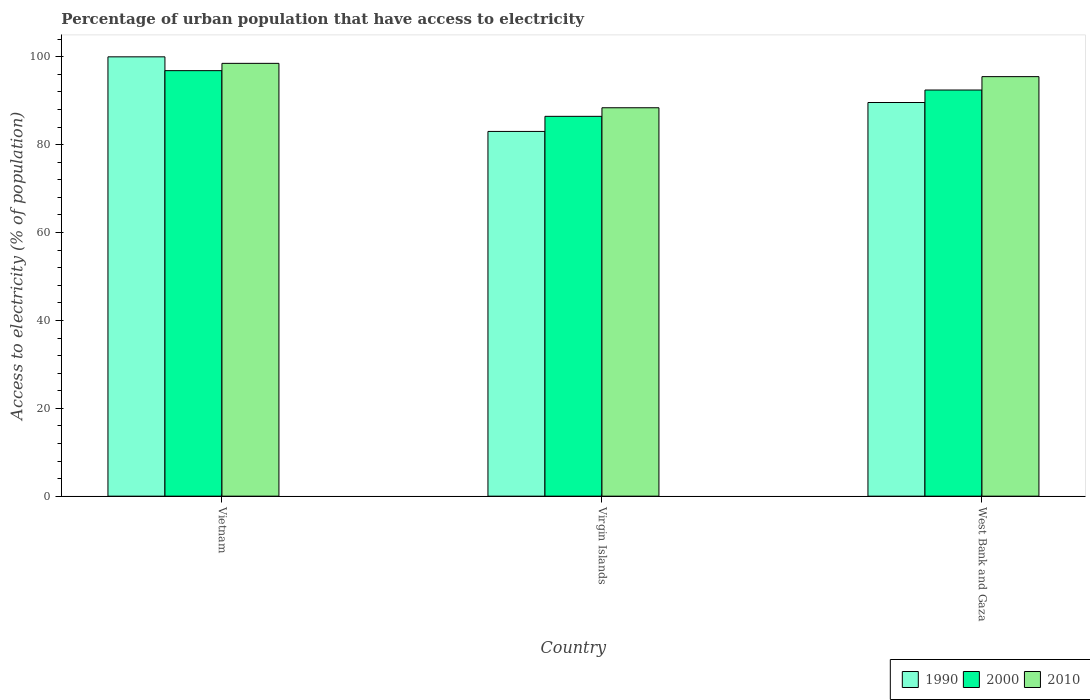How many groups of bars are there?
Keep it short and to the point. 3. Are the number of bars on each tick of the X-axis equal?
Your answer should be compact. Yes. How many bars are there on the 3rd tick from the right?
Your answer should be very brief. 3. What is the label of the 1st group of bars from the left?
Your answer should be compact. Vietnam. What is the percentage of urban population that have access to electricity in 2000 in West Bank and Gaza?
Your answer should be compact. 92.45. Across all countries, what is the maximum percentage of urban population that have access to electricity in 2010?
Ensure brevity in your answer.  98.52. Across all countries, what is the minimum percentage of urban population that have access to electricity in 1990?
Ensure brevity in your answer.  83.02. In which country was the percentage of urban population that have access to electricity in 1990 maximum?
Your answer should be very brief. Vietnam. In which country was the percentage of urban population that have access to electricity in 1990 minimum?
Make the answer very short. Virgin Islands. What is the total percentage of urban population that have access to electricity in 1990 in the graph?
Your answer should be very brief. 272.63. What is the difference between the percentage of urban population that have access to electricity in 2010 in Vietnam and that in West Bank and Gaza?
Give a very brief answer. 3.02. What is the difference between the percentage of urban population that have access to electricity in 2000 in West Bank and Gaza and the percentage of urban population that have access to electricity in 1990 in Vietnam?
Keep it short and to the point. -7.55. What is the average percentage of urban population that have access to electricity in 2000 per country?
Ensure brevity in your answer.  91.92. What is the difference between the percentage of urban population that have access to electricity of/in 2010 and percentage of urban population that have access to electricity of/in 2000 in West Bank and Gaza?
Your answer should be compact. 3.05. In how many countries, is the percentage of urban population that have access to electricity in 1990 greater than 88 %?
Provide a short and direct response. 2. What is the ratio of the percentage of urban population that have access to electricity in 1990 in Vietnam to that in Virgin Islands?
Your answer should be very brief. 1.2. Is the percentage of urban population that have access to electricity in 2010 in Virgin Islands less than that in West Bank and Gaza?
Keep it short and to the point. Yes. Is the difference between the percentage of urban population that have access to electricity in 2010 in Vietnam and West Bank and Gaza greater than the difference between the percentage of urban population that have access to electricity in 2000 in Vietnam and West Bank and Gaza?
Give a very brief answer. No. What is the difference between the highest and the second highest percentage of urban population that have access to electricity in 1990?
Keep it short and to the point. 6.59. What is the difference between the highest and the lowest percentage of urban population that have access to electricity in 2000?
Your answer should be compact. 10.4. Is the sum of the percentage of urban population that have access to electricity in 2000 in Virgin Islands and West Bank and Gaza greater than the maximum percentage of urban population that have access to electricity in 1990 across all countries?
Your answer should be very brief. Yes. What does the 1st bar from the left in West Bank and Gaza represents?
Make the answer very short. 1990. What does the 2nd bar from the right in West Bank and Gaza represents?
Make the answer very short. 2000. Is it the case that in every country, the sum of the percentage of urban population that have access to electricity in 2010 and percentage of urban population that have access to electricity in 1990 is greater than the percentage of urban population that have access to electricity in 2000?
Your answer should be compact. Yes. Does the graph contain grids?
Provide a short and direct response. No. Where does the legend appear in the graph?
Offer a very short reply. Bottom right. How many legend labels are there?
Give a very brief answer. 3. What is the title of the graph?
Your answer should be compact. Percentage of urban population that have access to electricity. Does "1963" appear as one of the legend labels in the graph?
Your response must be concise. No. What is the label or title of the X-axis?
Your answer should be compact. Country. What is the label or title of the Y-axis?
Your answer should be compact. Access to electricity (% of population). What is the Access to electricity (% of population) in 2000 in Vietnam?
Provide a short and direct response. 96.86. What is the Access to electricity (% of population) of 2010 in Vietnam?
Make the answer very short. 98.52. What is the Access to electricity (% of population) of 1990 in Virgin Islands?
Offer a very short reply. 83.02. What is the Access to electricity (% of population) of 2000 in Virgin Islands?
Provide a succinct answer. 86.46. What is the Access to electricity (% of population) of 2010 in Virgin Islands?
Give a very brief answer. 88.41. What is the Access to electricity (% of population) in 1990 in West Bank and Gaza?
Provide a short and direct response. 89.61. What is the Access to electricity (% of population) in 2000 in West Bank and Gaza?
Your response must be concise. 92.45. What is the Access to electricity (% of population) of 2010 in West Bank and Gaza?
Offer a very short reply. 95.5. Across all countries, what is the maximum Access to electricity (% of population) in 1990?
Provide a succinct answer. 100. Across all countries, what is the maximum Access to electricity (% of population) of 2000?
Give a very brief answer. 96.86. Across all countries, what is the maximum Access to electricity (% of population) in 2010?
Offer a terse response. 98.52. Across all countries, what is the minimum Access to electricity (% of population) in 1990?
Offer a very short reply. 83.02. Across all countries, what is the minimum Access to electricity (% of population) of 2000?
Give a very brief answer. 86.46. Across all countries, what is the minimum Access to electricity (% of population) in 2010?
Your response must be concise. 88.41. What is the total Access to electricity (% of population) in 1990 in the graph?
Give a very brief answer. 272.63. What is the total Access to electricity (% of population) of 2000 in the graph?
Your answer should be compact. 275.76. What is the total Access to electricity (% of population) of 2010 in the graph?
Give a very brief answer. 282.43. What is the difference between the Access to electricity (% of population) of 1990 in Vietnam and that in Virgin Islands?
Your answer should be compact. 16.98. What is the difference between the Access to electricity (% of population) of 2000 in Vietnam and that in Virgin Islands?
Make the answer very short. 10.4. What is the difference between the Access to electricity (% of population) in 2010 in Vietnam and that in Virgin Islands?
Keep it short and to the point. 10.11. What is the difference between the Access to electricity (% of population) in 1990 in Vietnam and that in West Bank and Gaza?
Offer a terse response. 10.39. What is the difference between the Access to electricity (% of population) in 2000 in Vietnam and that in West Bank and Gaza?
Your answer should be compact. 4.41. What is the difference between the Access to electricity (% of population) in 2010 in Vietnam and that in West Bank and Gaza?
Make the answer very short. 3.02. What is the difference between the Access to electricity (% of population) of 1990 in Virgin Islands and that in West Bank and Gaza?
Keep it short and to the point. -6.59. What is the difference between the Access to electricity (% of population) in 2000 in Virgin Islands and that in West Bank and Gaza?
Give a very brief answer. -5.99. What is the difference between the Access to electricity (% of population) of 2010 in Virgin Islands and that in West Bank and Gaza?
Make the answer very short. -7.08. What is the difference between the Access to electricity (% of population) in 1990 in Vietnam and the Access to electricity (% of population) in 2000 in Virgin Islands?
Provide a short and direct response. 13.54. What is the difference between the Access to electricity (% of population) of 1990 in Vietnam and the Access to electricity (% of population) of 2010 in Virgin Islands?
Make the answer very short. 11.59. What is the difference between the Access to electricity (% of population) of 2000 in Vietnam and the Access to electricity (% of population) of 2010 in Virgin Islands?
Your answer should be compact. 8.45. What is the difference between the Access to electricity (% of population) of 1990 in Vietnam and the Access to electricity (% of population) of 2000 in West Bank and Gaza?
Keep it short and to the point. 7.55. What is the difference between the Access to electricity (% of population) of 1990 in Vietnam and the Access to electricity (% of population) of 2010 in West Bank and Gaza?
Your answer should be compact. 4.5. What is the difference between the Access to electricity (% of population) in 2000 in Vietnam and the Access to electricity (% of population) in 2010 in West Bank and Gaza?
Your answer should be compact. 1.36. What is the difference between the Access to electricity (% of population) of 1990 in Virgin Islands and the Access to electricity (% of population) of 2000 in West Bank and Gaza?
Keep it short and to the point. -9.43. What is the difference between the Access to electricity (% of population) in 1990 in Virgin Islands and the Access to electricity (% of population) in 2010 in West Bank and Gaza?
Offer a very short reply. -12.47. What is the difference between the Access to electricity (% of population) of 2000 in Virgin Islands and the Access to electricity (% of population) of 2010 in West Bank and Gaza?
Your response must be concise. -9.04. What is the average Access to electricity (% of population) of 1990 per country?
Ensure brevity in your answer.  90.88. What is the average Access to electricity (% of population) of 2000 per country?
Offer a very short reply. 91.92. What is the average Access to electricity (% of population) in 2010 per country?
Give a very brief answer. 94.14. What is the difference between the Access to electricity (% of population) in 1990 and Access to electricity (% of population) in 2000 in Vietnam?
Give a very brief answer. 3.14. What is the difference between the Access to electricity (% of population) of 1990 and Access to electricity (% of population) of 2010 in Vietnam?
Ensure brevity in your answer.  1.48. What is the difference between the Access to electricity (% of population) of 2000 and Access to electricity (% of population) of 2010 in Vietnam?
Provide a short and direct response. -1.66. What is the difference between the Access to electricity (% of population) of 1990 and Access to electricity (% of population) of 2000 in Virgin Islands?
Offer a terse response. -3.44. What is the difference between the Access to electricity (% of population) of 1990 and Access to electricity (% of population) of 2010 in Virgin Islands?
Your answer should be compact. -5.39. What is the difference between the Access to electricity (% of population) of 2000 and Access to electricity (% of population) of 2010 in Virgin Islands?
Ensure brevity in your answer.  -1.95. What is the difference between the Access to electricity (% of population) in 1990 and Access to electricity (% of population) in 2000 in West Bank and Gaza?
Keep it short and to the point. -2.84. What is the difference between the Access to electricity (% of population) of 1990 and Access to electricity (% of population) of 2010 in West Bank and Gaza?
Your answer should be compact. -5.89. What is the difference between the Access to electricity (% of population) of 2000 and Access to electricity (% of population) of 2010 in West Bank and Gaza?
Keep it short and to the point. -3.05. What is the ratio of the Access to electricity (% of population) in 1990 in Vietnam to that in Virgin Islands?
Provide a succinct answer. 1.2. What is the ratio of the Access to electricity (% of population) in 2000 in Vietnam to that in Virgin Islands?
Ensure brevity in your answer.  1.12. What is the ratio of the Access to electricity (% of population) in 2010 in Vietnam to that in Virgin Islands?
Your answer should be compact. 1.11. What is the ratio of the Access to electricity (% of population) of 1990 in Vietnam to that in West Bank and Gaza?
Give a very brief answer. 1.12. What is the ratio of the Access to electricity (% of population) in 2000 in Vietnam to that in West Bank and Gaza?
Provide a short and direct response. 1.05. What is the ratio of the Access to electricity (% of population) in 2010 in Vietnam to that in West Bank and Gaza?
Make the answer very short. 1.03. What is the ratio of the Access to electricity (% of population) in 1990 in Virgin Islands to that in West Bank and Gaza?
Keep it short and to the point. 0.93. What is the ratio of the Access to electricity (% of population) of 2000 in Virgin Islands to that in West Bank and Gaza?
Your answer should be very brief. 0.94. What is the ratio of the Access to electricity (% of population) of 2010 in Virgin Islands to that in West Bank and Gaza?
Ensure brevity in your answer.  0.93. What is the difference between the highest and the second highest Access to electricity (% of population) of 1990?
Make the answer very short. 10.39. What is the difference between the highest and the second highest Access to electricity (% of population) of 2000?
Provide a succinct answer. 4.41. What is the difference between the highest and the second highest Access to electricity (% of population) of 2010?
Your answer should be very brief. 3.02. What is the difference between the highest and the lowest Access to electricity (% of population) of 1990?
Ensure brevity in your answer.  16.98. What is the difference between the highest and the lowest Access to electricity (% of population) of 2000?
Provide a succinct answer. 10.4. What is the difference between the highest and the lowest Access to electricity (% of population) in 2010?
Provide a short and direct response. 10.11. 